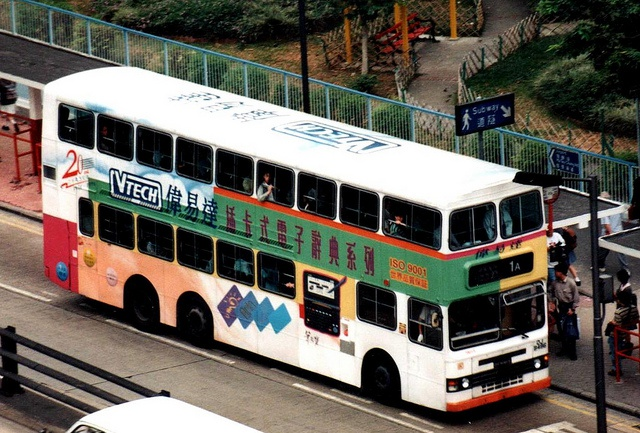Describe the objects in this image and their specific colors. I can see bus in darkgreen, black, white, tan, and gray tones, people in darkgreen, black, gray, and maroon tones, people in darkgreen, black, gray, maroon, and darkgray tones, people in darkgreen, black, darkgray, and gray tones, and people in darkgreen, black, lightgray, darkgray, and gray tones in this image. 